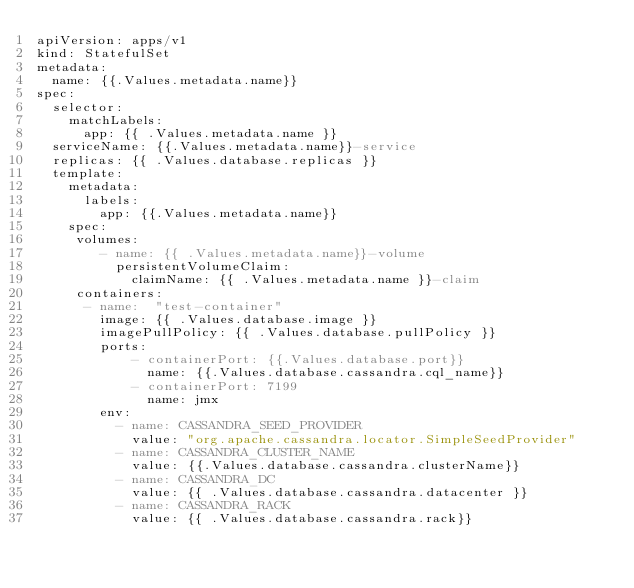Convert code to text. <code><loc_0><loc_0><loc_500><loc_500><_YAML_>apiVersion: apps/v1
kind: StatefulSet
metadata:
  name: {{.Values.metadata.name}}
spec:
  selector:
    matchLabels:
      app: {{ .Values.metadata.name }}
  serviceName: {{.Values.metadata.name}}-service
  replicas: {{ .Values.database.replicas }}
  template:
    metadata:
      labels:
        app: {{.Values.metadata.name}}
    spec:
     volumes:
        - name: {{ .Values.metadata.name}}-volume
          persistentVolumeClaim:
            claimName: {{ .Values.metadata.name }}-claim
     containers:
      - name:  "test-container"
        image: {{ .Values.database.image }}
        imagePullPolicy: {{ .Values.database.pullPolicy }}
        ports:
            - containerPort: {{.Values.database.port}}
              name: {{.Values.database.cassandra.cql_name}} 
            - containerPort: 7199
              name: jmx
        env:
          - name: CASSANDRA_SEED_PROVIDER
            value: "org.apache.cassandra.locator.SimpleSeedProvider"
          - name: CASSANDRA_CLUSTER_NAME
            value: {{.Values.database.cassandra.clusterName}}
          - name: CASSANDRA_DC
            value: {{ .Values.database.cassandra.datacenter }}
          - name: CASSANDRA_RACK
            value: {{ .Values.database.cassandra.rack}}   
          </code> 